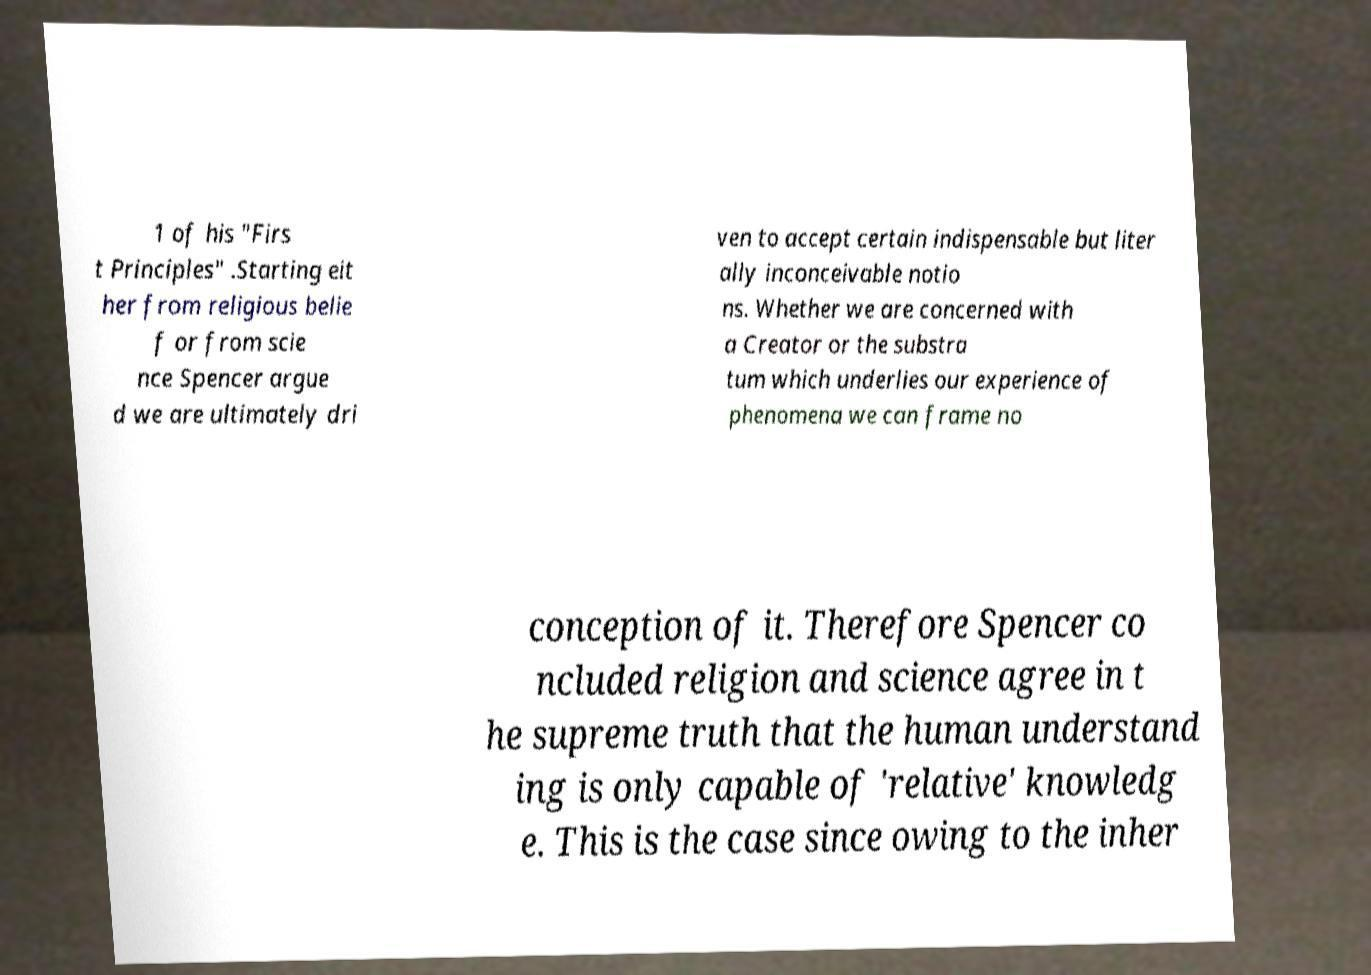Could you extract and type out the text from this image? 1 of his "Firs t Principles" .Starting eit her from religious belie f or from scie nce Spencer argue d we are ultimately dri ven to accept certain indispensable but liter ally inconceivable notio ns. Whether we are concerned with a Creator or the substra tum which underlies our experience of phenomena we can frame no conception of it. Therefore Spencer co ncluded religion and science agree in t he supreme truth that the human understand ing is only capable of 'relative' knowledg e. This is the case since owing to the inher 